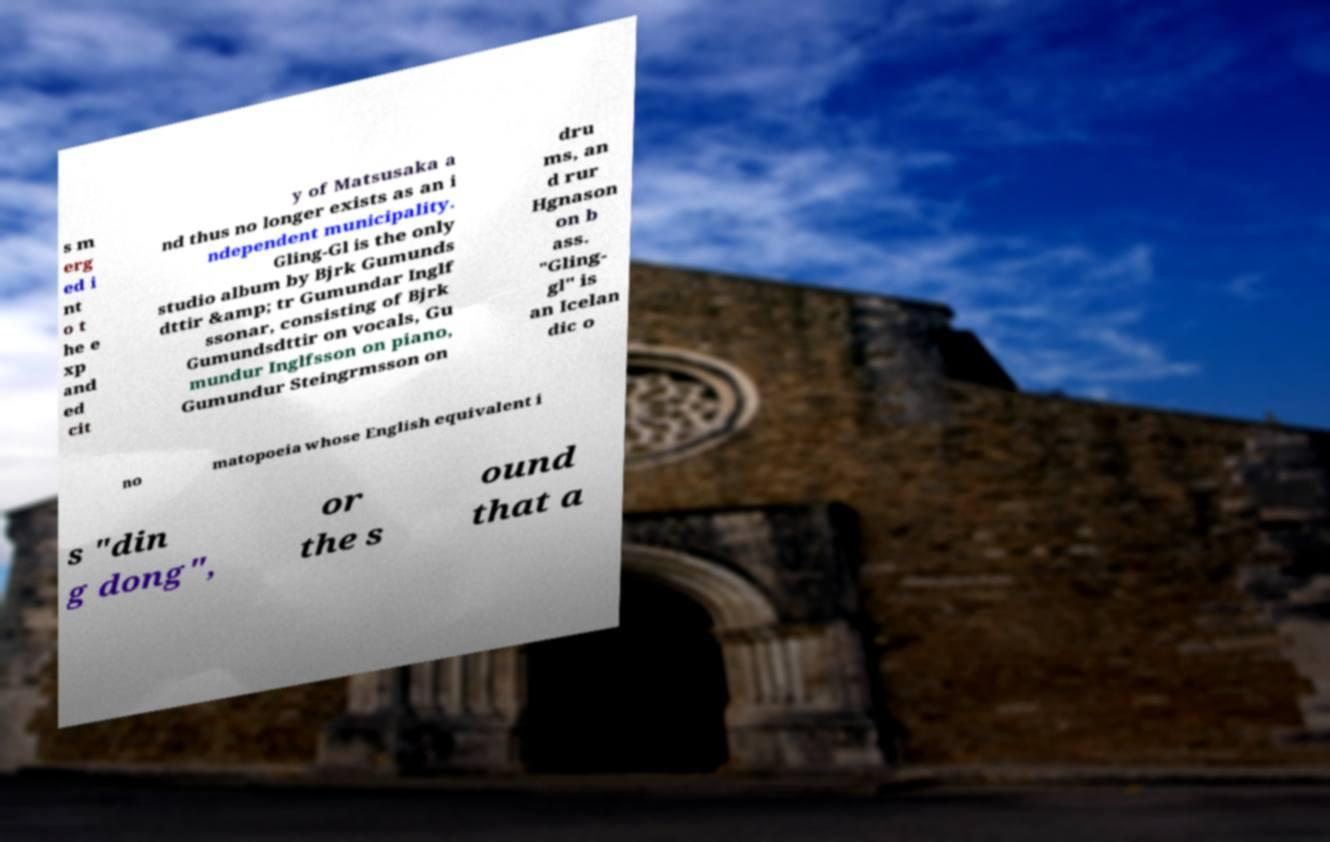Can you accurately transcribe the text from the provided image for me? s m erg ed i nt o t he e xp and ed cit y of Matsusaka a nd thus no longer exists as an i ndependent municipality. Gling-Gl is the only studio album by Bjrk Gumunds dttir &amp; tr Gumundar Inglf ssonar, consisting of Bjrk Gumundsdttir on vocals, Gu mundur Inglfsson on piano, Gumundur Steingrmsson on dru ms, an d rur Hgnason on b ass. "Gling- gl" is an Icelan dic o no matopoeia whose English equivalent i s "din g dong", or the s ound that a 